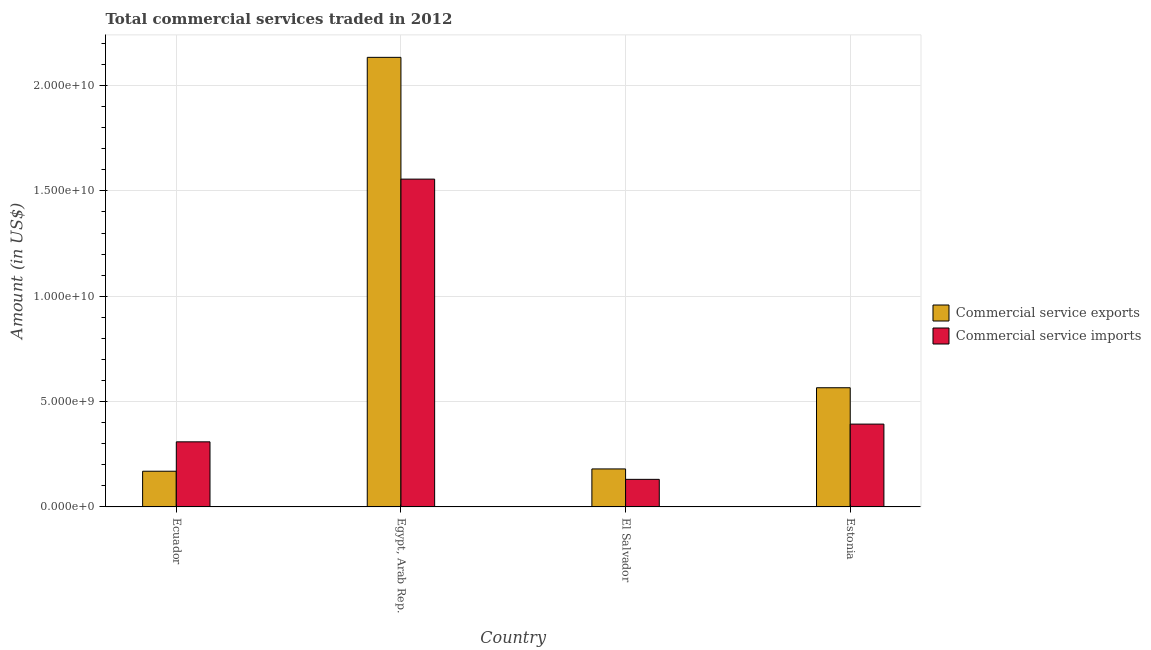Are the number of bars per tick equal to the number of legend labels?
Ensure brevity in your answer.  Yes. Are the number of bars on each tick of the X-axis equal?
Give a very brief answer. Yes. How many bars are there on the 4th tick from the left?
Offer a very short reply. 2. What is the label of the 4th group of bars from the left?
Provide a short and direct response. Estonia. What is the amount of commercial service imports in Ecuador?
Offer a terse response. 3.09e+09. Across all countries, what is the maximum amount of commercial service exports?
Your answer should be very brief. 2.13e+1. Across all countries, what is the minimum amount of commercial service imports?
Offer a very short reply. 1.31e+09. In which country was the amount of commercial service exports maximum?
Ensure brevity in your answer.  Egypt, Arab Rep. In which country was the amount of commercial service exports minimum?
Offer a very short reply. Ecuador. What is the total amount of commercial service imports in the graph?
Keep it short and to the point. 2.39e+1. What is the difference between the amount of commercial service exports in Egypt, Arab Rep. and that in El Salvador?
Make the answer very short. 1.95e+1. What is the difference between the amount of commercial service imports in Ecuador and the amount of commercial service exports in Egypt, Arab Rep.?
Keep it short and to the point. -1.82e+1. What is the average amount of commercial service exports per country?
Give a very brief answer. 7.62e+09. What is the difference between the amount of commercial service imports and amount of commercial service exports in Ecuador?
Keep it short and to the point. 1.40e+09. What is the ratio of the amount of commercial service exports in Egypt, Arab Rep. to that in El Salvador?
Offer a very short reply. 11.83. Is the amount of commercial service imports in Ecuador less than that in Estonia?
Offer a terse response. Yes. Is the difference between the amount of commercial service imports in Ecuador and Egypt, Arab Rep. greater than the difference between the amount of commercial service exports in Ecuador and Egypt, Arab Rep.?
Your answer should be compact. Yes. What is the difference between the highest and the second highest amount of commercial service exports?
Your answer should be compact. 1.57e+1. What is the difference between the highest and the lowest amount of commercial service imports?
Provide a succinct answer. 1.42e+1. What does the 1st bar from the left in Ecuador represents?
Your answer should be very brief. Commercial service exports. What does the 2nd bar from the right in El Salvador represents?
Your answer should be compact. Commercial service exports. How many countries are there in the graph?
Your answer should be compact. 4. What is the difference between two consecutive major ticks on the Y-axis?
Your response must be concise. 5.00e+09. Does the graph contain any zero values?
Provide a short and direct response. No. Does the graph contain grids?
Offer a terse response. Yes. What is the title of the graph?
Ensure brevity in your answer.  Total commercial services traded in 2012. Does "Age 15+" appear as one of the legend labels in the graph?
Provide a short and direct response. No. What is the label or title of the Y-axis?
Offer a very short reply. Amount (in US$). What is the Amount (in US$) of Commercial service exports in Ecuador?
Provide a succinct answer. 1.69e+09. What is the Amount (in US$) in Commercial service imports in Ecuador?
Offer a very short reply. 3.09e+09. What is the Amount (in US$) of Commercial service exports in Egypt, Arab Rep.?
Your answer should be very brief. 2.13e+1. What is the Amount (in US$) of Commercial service imports in Egypt, Arab Rep.?
Your answer should be compact. 1.56e+1. What is the Amount (in US$) of Commercial service exports in El Salvador?
Offer a very short reply. 1.80e+09. What is the Amount (in US$) of Commercial service imports in El Salvador?
Your answer should be very brief. 1.31e+09. What is the Amount (in US$) of Commercial service exports in Estonia?
Ensure brevity in your answer.  5.66e+09. What is the Amount (in US$) of Commercial service imports in Estonia?
Provide a succinct answer. 3.93e+09. Across all countries, what is the maximum Amount (in US$) in Commercial service exports?
Provide a short and direct response. 2.13e+1. Across all countries, what is the maximum Amount (in US$) in Commercial service imports?
Make the answer very short. 1.56e+1. Across all countries, what is the minimum Amount (in US$) in Commercial service exports?
Ensure brevity in your answer.  1.69e+09. Across all countries, what is the minimum Amount (in US$) of Commercial service imports?
Provide a short and direct response. 1.31e+09. What is the total Amount (in US$) in Commercial service exports in the graph?
Offer a terse response. 3.05e+1. What is the total Amount (in US$) of Commercial service imports in the graph?
Offer a terse response. 2.39e+1. What is the difference between the Amount (in US$) of Commercial service exports in Ecuador and that in Egypt, Arab Rep.?
Your answer should be very brief. -1.96e+1. What is the difference between the Amount (in US$) of Commercial service imports in Ecuador and that in Egypt, Arab Rep.?
Your answer should be very brief. -1.25e+1. What is the difference between the Amount (in US$) in Commercial service exports in Ecuador and that in El Salvador?
Make the answer very short. -1.09e+08. What is the difference between the Amount (in US$) of Commercial service imports in Ecuador and that in El Salvador?
Ensure brevity in your answer.  1.78e+09. What is the difference between the Amount (in US$) of Commercial service exports in Ecuador and that in Estonia?
Offer a terse response. -3.96e+09. What is the difference between the Amount (in US$) of Commercial service imports in Ecuador and that in Estonia?
Provide a short and direct response. -8.42e+08. What is the difference between the Amount (in US$) of Commercial service exports in Egypt, Arab Rep. and that in El Salvador?
Your response must be concise. 1.95e+1. What is the difference between the Amount (in US$) in Commercial service imports in Egypt, Arab Rep. and that in El Salvador?
Provide a succinct answer. 1.42e+1. What is the difference between the Amount (in US$) of Commercial service exports in Egypt, Arab Rep. and that in Estonia?
Make the answer very short. 1.57e+1. What is the difference between the Amount (in US$) in Commercial service imports in Egypt, Arab Rep. and that in Estonia?
Your answer should be compact. 1.16e+1. What is the difference between the Amount (in US$) of Commercial service exports in El Salvador and that in Estonia?
Offer a very short reply. -3.85e+09. What is the difference between the Amount (in US$) of Commercial service imports in El Salvador and that in Estonia?
Provide a succinct answer. -2.62e+09. What is the difference between the Amount (in US$) in Commercial service exports in Ecuador and the Amount (in US$) in Commercial service imports in Egypt, Arab Rep.?
Offer a very short reply. -1.39e+1. What is the difference between the Amount (in US$) of Commercial service exports in Ecuador and the Amount (in US$) of Commercial service imports in El Salvador?
Your answer should be compact. 3.85e+08. What is the difference between the Amount (in US$) of Commercial service exports in Ecuador and the Amount (in US$) of Commercial service imports in Estonia?
Make the answer very short. -2.24e+09. What is the difference between the Amount (in US$) in Commercial service exports in Egypt, Arab Rep. and the Amount (in US$) in Commercial service imports in El Salvador?
Keep it short and to the point. 2.00e+1. What is the difference between the Amount (in US$) of Commercial service exports in Egypt, Arab Rep. and the Amount (in US$) of Commercial service imports in Estonia?
Make the answer very short. 1.74e+1. What is the difference between the Amount (in US$) of Commercial service exports in El Salvador and the Amount (in US$) of Commercial service imports in Estonia?
Provide a short and direct response. -2.13e+09. What is the average Amount (in US$) of Commercial service exports per country?
Provide a succinct answer. 7.62e+09. What is the average Amount (in US$) of Commercial service imports per country?
Provide a succinct answer. 5.97e+09. What is the difference between the Amount (in US$) in Commercial service exports and Amount (in US$) in Commercial service imports in Ecuador?
Your answer should be very brief. -1.40e+09. What is the difference between the Amount (in US$) of Commercial service exports and Amount (in US$) of Commercial service imports in Egypt, Arab Rep.?
Provide a succinct answer. 5.78e+09. What is the difference between the Amount (in US$) of Commercial service exports and Amount (in US$) of Commercial service imports in El Salvador?
Provide a short and direct response. 4.94e+08. What is the difference between the Amount (in US$) of Commercial service exports and Amount (in US$) of Commercial service imports in Estonia?
Provide a succinct answer. 1.73e+09. What is the ratio of the Amount (in US$) of Commercial service exports in Ecuador to that in Egypt, Arab Rep.?
Offer a terse response. 0.08. What is the ratio of the Amount (in US$) in Commercial service imports in Ecuador to that in Egypt, Arab Rep.?
Give a very brief answer. 0.2. What is the ratio of the Amount (in US$) of Commercial service exports in Ecuador to that in El Salvador?
Your answer should be compact. 0.94. What is the ratio of the Amount (in US$) of Commercial service imports in Ecuador to that in El Salvador?
Make the answer very short. 2.36. What is the ratio of the Amount (in US$) of Commercial service exports in Ecuador to that in Estonia?
Keep it short and to the point. 0.3. What is the ratio of the Amount (in US$) in Commercial service imports in Ecuador to that in Estonia?
Your answer should be very brief. 0.79. What is the ratio of the Amount (in US$) in Commercial service exports in Egypt, Arab Rep. to that in El Salvador?
Offer a terse response. 11.83. What is the ratio of the Amount (in US$) of Commercial service imports in Egypt, Arab Rep. to that in El Salvador?
Your answer should be compact. 11.88. What is the ratio of the Amount (in US$) of Commercial service exports in Egypt, Arab Rep. to that in Estonia?
Your answer should be very brief. 3.77. What is the ratio of the Amount (in US$) in Commercial service imports in Egypt, Arab Rep. to that in Estonia?
Your answer should be compact. 3.96. What is the ratio of the Amount (in US$) in Commercial service exports in El Salvador to that in Estonia?
Ensure brevity in your answer.  0.32. What is the ratio of the Amount (in US$) of Commercial service imports in El Salvador to that in Estonia?
Keep it short and to the point. 0.33. What is the difference between the highest and the second highest Amount (in US$) in Commercial service exports?
Your answer should be compact. 1.57e+1. What is the difference between the highest and the second highest Amount (in US$) in Commercial service imports?
Your answer should be compact. 1.16e+1. What is the difference between the highest and the lowest Amount (in US$) of Commercial service exports?
Offer a terse response. 1.96e+1. What is the difference between the highest and the lowest Amount (in US$) of Commercial service imports?
Keep it short and to the point. 1.42e+1. 